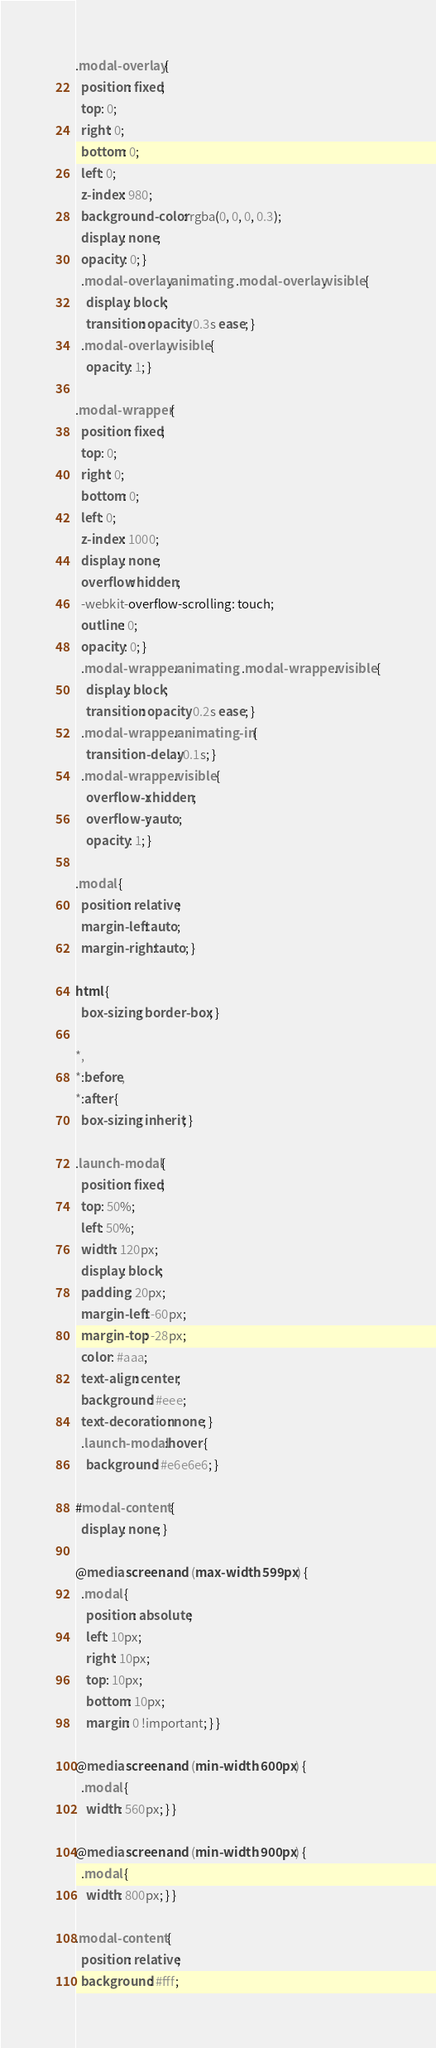Convert code to text. <code><loc_0><loc_0><loc_500><loc_500><_CSS_>.modal-overlay {
  position: fixed;
  top: 0;
  right: 0;
  bottom: 0;
  left: 0;
  z-index: 980;
  background-color: rgba(0, 0, 0, 0.3);
  display: none;
  opacity: 0; }
  .modal-overlay.animating, .modal-overlay.visible {
    display: block;
    transition: opacity 0.3s ease; }
  .modal-overlay.visible {
    opacity: 1; }

.modal-wrapper {
  position: fixed;
  top: 0;
  right: 0;
  bottom: 0;
  left: 0;
  z-index: 1000;
  display: none;
  overflow: hidden;
  -webkit-overflow-scrolling: touch;
  outline: 0;
  opacity: 0; }
  .modal-wrapper.animating, .modal-wrapper.visible {
    display: block;
    transition: opacity 0.2s ease; }
  .modal-wrapper.animating-in {
    transition-delay: 0.1s; }
  .modal-wrapper.visible {
    overflow-x: hidden;
    overflow-y: auto;
    opacity: 1; }

.modal {
  position: relative;
  margin-left: auto;
  margin-right: auto; }

html {
  box-sizing: border-box; }

*,
*:before,
*:after {
  box-sizing: inherit; }

.launch-modal {
  position: fixed;
  top: 50%;
  left: 50%;
  width: 120px;
  display: block;
  padding: 20px;
  margin-left: -60px;
  margin-top: -28px;
  color: #aaa;
  text-align: center;
  background: #eee;
  text-decoration: none; }
  .launch-modal:hover {
    background: #e6e6e6; }

#modal-content {
  display: none; }

@media screen and (max-width: 599px) {
  .modal {
    position: absolute;
    left: 10px;
    right: 10px;
    top: 10px;
    bottom: 10px;
    margin: 0 !important; } }

@media screen and (min-width: 600px) {
  .modal {
    width: 560px; } }

@media screen and (min-width: 900px) {
  .modal {
    width: 800px; } }

.modal-content {
  position: relative;
  background: #fff;</code> 